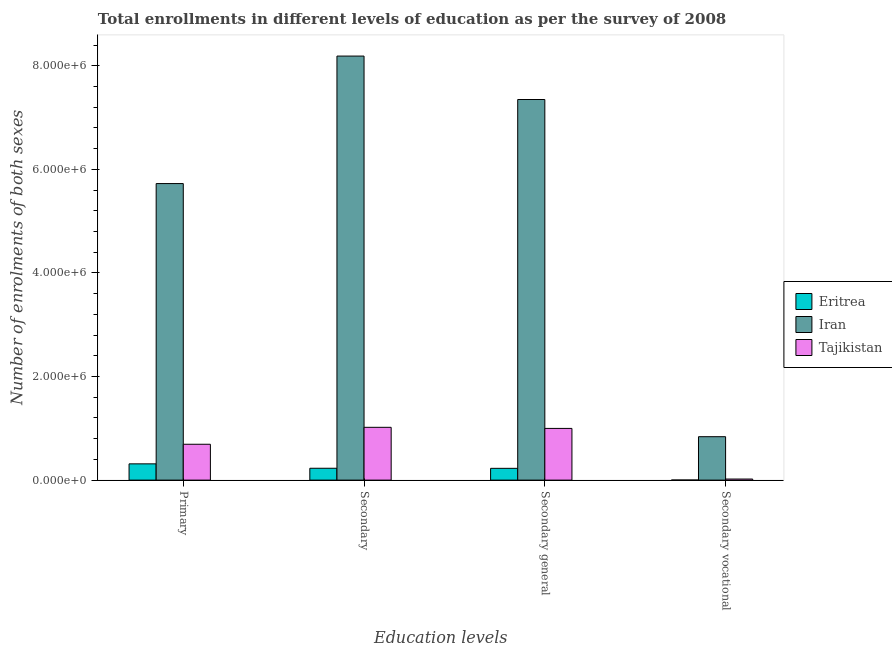How many different coloured bars are there?
Your answer should be very brief. 3. How many groups of bars are there?
Give a very brief answer. 4. Are the number of bars per tick equal to the number of legend labels?
Make the answer very short. Yes. How many bars are there on the 1st tick from the left?
Your response must be concise. 3. How many bars are there on the 2nd tick from the right?
Make the answer very short. 3. What is the label of the 1st group of bars from the left?
Make the answer very short. Primary. What is the number of enrolments in secondary education in Eritrea?
Your answer should be compact. 2.29e+05. Across all countries, what is the maximum number of enrolments in secondary education?
Provide a short and direct response. 8.19e+06. Across all countries, what is the minimum number of enrolments in primary education?
Offer a very short reply. 3.14e+05. In which country was the number of enrolments in secondary general education maximum?
Provide a succinct answer. Iran. In which country was the number of enrolments in secondary vocational education minimum?
Your response must be concise. Eritrea. What is the total number of enrolments in secondary general education in the graph?
Offer a terse response. 8.57e+06. What is the difference between the number of enrolments in secondary education in Eritrea and that in Iran?
Provide a short and direct response. -7.96e+06. What is the difference between the number of enrolments in secondary vocational education in Tajikistan and the number of enrolments in secondary general education in Eritrea?
Make the answer very short. -2.07e+05. What is the average number of enrolments in primary education per country?
Provide a short and direct response. 2.24e+06. What is the difference between the number of enrolments in primary education and number of enrolments in secondary general education in Iran?
Your answer should be compact. -1.62e+06. What is the ratio of the number of enrolments in secondary general education in Tajikistan to that in Iran?
Offer a terse response. 0.14. What is the difference between the highest and the second highest number of enrolments in secondary education?
Give a very brief answer. 7.17e+06. What is the difference between the highest and the lowest number of enrolments in secondary education?
Offer a terse response. 7.96e+06. What does the 1st bar from the left in Primary represents?
Your answer should be compact. Eritrea. What does the 3rd bar from the right in Secondary vocational represents?
Keep it short and to the point. Eritrea. Is it the case that in every country, the sum of the number of enrolments in primary education and number of enrolments in secondary education is greater than the number of enrolments in secondary general education?
Provide a succinct answer. Yes. How many bars are there?
Your answer should be very brief. 12. How many countries are there in the graph?
Your response must be concise. 3. Does the graph contain any zero values?
Your response must be concise. No. Where does the legend appear in the graph?
Ensure brevity in your answer.  Center right. What is the title of the graph?
Your answer should be compact. Total enrollments in different levels of education as per the survey of 2008. What is the label or title of the X-axis?
Your response must be concise. Education levels. What is the label or title of the Y-axis?
Keep it short and to the point. Number of enrolments of both sexes. What is the Number of enrolments of both sexes of Eritrea in Primary?
Offer a very short reply. 3.14e+05. What is the Number of enrolments of both sexes in Iran in Primary?
Keep it short and to the point. 5.73e+06. What is the Number of enrolments of both sexes in Tajikistan in Primary?
Provide a succinct answer. 6.92e+05. What is the Number of enrolments of both sexes in Eritrea in Secondary?
Keep it short and to the point. 2.29e+05. What is the Number of enrolments of both sexes in Iran in Secondary?
Your answer should be compact. 8.19e+06. What is the Number of enrolments of both sexes in Tajikistan in Secondary?
Provide a succinct answer. 1.02e+06. What is the Number of enrolments of both sexes in Eritrea in Secondary general?
Your response must be concise. 2.27e+05. What is the Number of enrolments of both sexes in Iran in Secondary general?
Make the answer very short. 7.35e+06. What is the Number of enrolments of both sexes in Tajikistan in Secondary general?
Provide a short and direct response. 9.98e+05. What is the Number of enrolments of both sexes in Eritrea in Secondary vocational?
Keep it short and to the point. 1637. What is the Number of enrolments of both sexes of Iran in Secondary vocational?
Give a very brief answer. 8.38e+05. What is the Number of enrolments of both sexes in Tajikistan in Secondary vocational?
Offer a very short reply. 2.09e+04. Across all Education levels, what is the maximum Number of enrolments of both sexes in Eritrea?
Give a very brief answer. 3.14e+05. Across all Education levels, what is the maximum Number of enrolments of both sexes of Iran?
Your response must be concise. 8.19e+06. Across all Education levels, what is the maximum Number of enrolments of both sexes in Tajikistan?
Your answer should be compact. 1.02e+06. Across all Education levels, what is the minimum Number of enrolments of both sexes in Eritrea?
Ensure brevity in your answer.  1637. Across all Education levels, what is the minimum Number of enrolments of both sexes in Iran?
Make the answer very short. 8.38e+05. Across all Education levels, what is the minimum Number of enrolments of both sexes of Tajikistan?
Your answer should be compact. 2.09e+04. What is the total Number of enrolments of both sexes of Eritrea in the graph?
Keep it short and to the point. 7.72e+05. What is the total Number of enrolments of both sexes in Iran in the graph?
Provide a succinct answer. 2.21e+07. What is the total Number of enrolments of both sexes in Tajikistan in the graph?
Your answer should be compact. 2.73e+06. What is the difference between the Number of enrolments of both sexes in Eritrea in Primary and that in Secondary?
Provide a short and direct response. 8.50e+04. What is the difference between the Number of enrolments of both sexes of Iran in Primary and that in Secondary?
Your answer should be compact. -2.46e+06. What is the difference between the Number of enrolments of both sexes of Tajikistan in Primary and that in Secondary?
Your response must be concise. -3.27e+05. What is the difference between the Number of enrolments of both sexes in Eritrea in Primary and that in Secondary general?
Make the answer very short. 8.66e+04. What is the difference between the Number of enrolments of both sexes of Iran in Primary and that in Secondary general?
Make the answer very short. -1.62e+06. What is the difference between the Number of enrolments of both sexes of Tajikistan in Primary and that in Secondary general?
Your answer should be very brief. -3.06e+05. What is the difference between the Number of enrolments of both sexes in Eritrea in Primary and that in Secondary vocational?
Your response must be concise. 3.12e+05. What is the difference between the Number of enrolments of both sexes in Iran in Primary and that in Secondary vocational?
Offer a very short reply. 4.89e+06. What is the difference between the Number of enrolments of both sexes of Tajikistan in Primary and that in Secondary vocational?
Keep it short and to the point. 6.71e+05. What is the difference between the Number of enrolments of both sexes in Eritrea in Secondary and that in Secondary general?
Offer a very short reply. 1637. What is the difference between the Number of enrolments of both sexes of Iran in Secondary and that in Secondary general?
Provide a succinct answer. 8.38e+05. What is the difference between the Number of enrolments of both sexes in Tajikistan in Secondary and that in Secondary general?
Provide a succinct answer. 2.09e+04. What is the difference between the Number of enrolments of both sexes of Eritrea in Secondary and that in Secondary vocational?
Your response must be concise. 2.27e+05. What is the difference between the Number of enrolments of both sexes of Iran in Secondary and that in Secondary vocational?
Make the answer very short. 7.35e+06. What is the difference between the Number of enrolments of both sexes in Tajikistan in Secondary and that in Secondary vocational?
Ensure brevity in your answer.  9.98e+05. What is the difference between the Number of enrolments of both sexes in Eritrea in Secondary general and that in Secondary vocational?
Provide a succinct answer. 2.26e+05. What is the difference between the Number of enrolments of both sexes of Iran in Secondary general and that in Secondary vocational?
Ensure brevity in your answer.  6.51e+06. What is the difference between the Number of enrolments of both sexes in Tajikistan in Secondary general and that in Secondary vocational?
Give a very brief answer. 9.77e+05. What is the difference between the Number of enrolments of both sexes of Eritrea in Primary and the Number of enrolments of both sexes of Iran in Secondary?
Provide a succinct answer. -7.87e+06. What is the difference between the Number of enrolments of both sexes in Eritrea in Primary and the Number of enrolments of both sexes in Tajikistan in Secondary?
Offer a terse response. -7.05e+05. What is the difference between the Number of enrolments of both sexes in Iran in Primary and the Number of enrolments of both sexes in Tajikistan in Secondary?
Provide a succinct answer. 4.71e+06. What is the difference between the Number of enrolments of both sexes of Eritrea in Primary and the Number of enrolments of both sexes of Iran in Secondary general?
Keep it short and to the point. -7.03e+06. What is the difference between the Number of enrolments of both sexes in Eritrea in Primary and the Number of enrolments of both sexes in Tajikistan in Secondary general?
Your answer should be compact. -6.84e+05. What is the difference between the Number of enrolments of both sexes of Iran in Primary and the Number of enrolments of both sexes of Tajikistan in Secondary general?
Ensure brevity in your answer.  4.73e+06. What is the difference between the Number of enrolments of both sexes of Eritrea in Primary and the Number of enrolments of both sexes of Iran in Secondary vocational?
Keep it short and to the point. -5.24e+05. What is the difference between the Number of enrolments of both sexes of Eritrea in Primary and the Number of enrolments of both sexes of Tajikistan in Secondary vocational?
Offer a very short reply. 2.93e+05. What is the difference between the Number of enrolments of both sexes in Iran in Primary and the Number of enrolments of both sexes in Tajikistan in Secondary vocational?
Ensure brevity in your answer.  5.70e+06. What is the difference between the Number of enrolments of both sexes in Eritrea in Secondary and the Number of enrolments of both sexes in Iran in Secondary general?
Provide a succinct answer. -7.12e+06. What is the difference between the Number of enrolments of both sexes in Eritrea in Secondary and the Number of enrolments of both sexes in Tajikistan in Secondary general?
Keep it short and to the point. -7.69e+05. What is the difference between the Number of enrolments of both sexes of Iran in Secondary and the Number of enrolments of both sexes of Tajikistan in Secondary general?
Your answer should be very brief. 7.19e+06. What is the difference between the Number of enrolments of both sexes of Eritrea in Secondary and the Number of enrolments of both sexes of Iran in Secondary vocational?
Make the answer very short. -6.09e+05. What is the difference between the Number of enrolments of both sexes in Eritrea in Secondary and the Number of enrolments of both sexes in Tajikistan in Secondary vocational?
Offer a very short reply. 2.08e+05. What is the difference between the Number of enrolments of both sexes of Iran in Secondary and the Number of enrolments of both sexes of Tajikistan in Secondary vocational?
Offer a terse response. 8.17e+06. What is the difference between the Number of enrolments of both sexes in Eritrea in Secondary general and the Number of enrolments of both sexes in Iran in Secondary vocational?
Ensure brevity in your answer.  -6.11e+05. What is the difference between the Number of enrolments of both sexes in Eritrea in Secondary general and the Number of enrolments of both sexes in Tajikistan in Secondary vocational?
Your answer should be compact. 2.07e+05. What is the difference between the Number of enrolments of both sexes in Iran in Secondary general and the Number of enrolments of both sexes in Tajikistan in Secondary vocational?
Give a very brief answer. 7.33e+06. What is the average Number of enrolments of both sexes of Eritrea per Education levels?
Keep it short and to the point. 1.93e+05. What is the average Number of enrolments of both sexes in Iran per Education levels?
Provide a succinct answer. 5.52e+06. What is the average Number of enrolments of both sexes of Tajikistan per Education levels?
Give a very brief answer. 6.83e+05. What is the difference between the Number of enrolments of both sexes in Eritrea and Number of enrolments of both sexes in Iran in Primary?
Offer a very short reply. -5.41e+06. What is the difference between the Number of enrolments of both sexes in Eritrea and Number of enrolments of both sexes in Tajikistan in Primary?
Ensure brevity in your answer.  -3.78e+05. What is the difference between the Number of enrolments of both sexes in Iran and Number of enrolments of both sexes in Tajikistan in Primary?
Make the answer very short. 5.03e+06. What is the difference between the Number of enrolments of both sexes of Eritrea and Number of enrolments of both sexes of Iran in Secondary?
Provide a short and direct response. -7.96e+06. What is the difference between the Number of enrolments of both sexes of Eritrea and Number of enrolments of both sexes of Tajikistan in Secondary?
Make the answer very short. -7.90e+05. What is the difference between the Number of enrolments of both sexes in Iran and Number of enrolments of both sexes in Tajikistan in Secondary?
Offer a very short reply. 7.17e+06. What is the difference between the Number of enrolments of both sexes in Eritrea and Number of enrolments of both sexes in Iran in Secondary general?
Provide a succinct answer. -7.12e+06. What is the difference between the Number of enrolments of both sexes in Eritrea and Number of enrolments of both sexes in Tajikistan in Secondary general?
Your answer should be very brief. -7.71e+05. What is the difference between the Number of enrolments of both sexes of Iran and Number of enrolments of both sexes of Tajikistan in Secondary general?
Make the answer very short. 6.35e+06. What is the difference between the Number of enrolments of both sexes of Eritrea and Number of enrolments of both sexes of Iran in Secondary vocational?
Offer a terse response. -8.37e+05. What is the difference between the Number of enrolments of both sexes of Eritrea and Number of enrolments of both sexes of Tajikistan in Secondary vocational?
Your answer should be compact. -1.93e+04. What is the difference between the Number of enrolments of both sexes of Iran and Number of enrolments of both sexes of Tajikistan in Secondary vocational?
Keep it short and to the point. 8.18e+05. What is the ratio of the Number of enrolments of both sexes of Eritrea in Primary to that in Secondary?
Ensure brevity in your answer.  1.37. What is the ratio of the Number of enrolments of both sexes of Iran in Primary to that in Secondary?
Provide a short and direct response. 0.7. What is the ratio of the Number of enrolments of both sexes of Tajikistan in Primary to that in Secondary?
Give a very brief answer. 0.68. What is the ratio of the Number of enrolments of both sexes of Eritrea in Primary to that in Secondary general?
Offer a terse response. 1.38. What is the ratio of the Number of enrolments of both sexes in Iran in Primary to that in Secondary general?
Your response must be concise. 0.78. What is the ratio of the Number of enrolments of both sexes of Tajikistan in Primary to that in Secondary general?
Offer a terse response. 0.69. What is the ratio of the Number of enrolments of both sexes in Eritrea in Primary to that in Secondary vocational?
Provide a short and direct response. 191.84. What is the ratio of the Number of enrolments of both sexes in Iran in Primary to that in Secondary vocational?
Your response must be concise. 6.83. What is the ratio of the Number of enrolments of both sexes in Tajikistan in Primary to that in Secondary vocational?
Offer a very short reply. 33.1. What is the ratio of the Number of enrolments of both sexes in Iran in Secondary to that in Secondary general?
Make the answer very short. 1.11. What is the ratio of the Number of enrolments of both sexes of Tajikistan in Secondary to that in Secondary general?
Keep it short and to the point. 1.02. What is the ratio of the Number of enrolments of both sexes of Eritrea in Secondary to that in Secondary vocational?
Offer a very short reply. 139.94. What is the ratio of the Number of enrolments of both sexes of Iran in Secondary to that in Secondary vocational?
Provide a succinct answer. 9.76. What is the ratio of the Number of enrolments of both sexes of Tajikistan in Secondary to that in Secondary vocational?
Your answer should be very brief. 48.74. What is the ratio of the Number of enrolments of both sexes of Eritrea in Secondary general to that in Secondary vocational?
Offer a very short reply. 138.94. What is the ratio of the Number of enrolments of both sexes in Iran in Secondary general to that in Secondary vocational?
Your response must be concise. 8.76. What is the ratio of the Number of enrolments of both sexes in Tajikistan in Secondary general to that in Secondary vocational?
Offer a terse response. 47.74. What is the difference between the highest and the second highest Number of enrolments of both sexes of Eritrea?
Your response must be concise. 8.50e+04. What is the difference between the highest and the second highest Number of enrolments of both sexes of Iran?
Provide a short and direct response. 8.38e+05. What is the difference between the highest and the second highest Number of enrolments of both sexes in Tajikistan?
Provide a short and direct response. 2.09e+04. What is the difference between the highest and the lowest Number of enrolments of both sexes in Eritrea?
Give a very brief answer. 3.12e+05. What is the difference between the highest and the lowest Number of enrolments of both sexes in Iran?
Your answer should be very brief. 7.35e+06. What is the difference between the highest and the lowest Number of enrolments of both sexes of Tajikistan?
Your answer should be compact. 9.98e+05. 